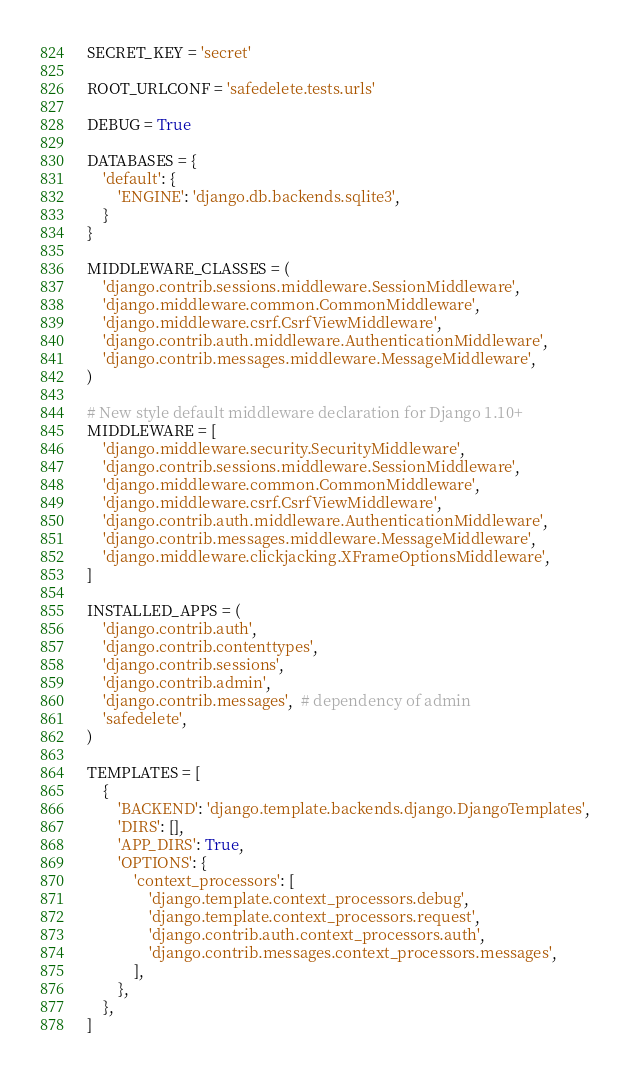<code> <loc_0><loc_0><loc_500><loc_500><_Python_>SECRET_KEY = 'secret'

ROOT_URLCONF = 'safedelete.tests.urls'

DEBUG = True

DATABASES = {
    'default': {
        'ENGINE': 'django.db.backends.sqlite3',
    }
}

MIDDLEWARE_CLASSES = (
    'django.contrib.sessions.middleware.SessionMiddleware',
    'django.middleware.common.CommonMiddleware',
    'django.middleware.csrf.CsrfViewMiddleware',
    'django.contrib.auth.middleware.AuthenticationMiddleware',
    'django.contrib.messages.middleware.MessageMiddleware',
)

# New style default middleware declaration for Django 1.10+
MIDDLEWARE = [
    'django.middleware.security.SecurityMiddleware',
    'django.contrib.sessions.middleware.SessionMiddleware',
    'django.middleware.common.CommonMiddleware',
    'django.middleware.csrf.CsrfViewMiddleware',
    'django.contrib.auth.middleware.AuthenticationMiddleware',
    'django.contrib.messages.middleware.MessageMiddleware',
    'django.middleware.clickjacking.XFrameOptionsMiddleware',
]

INSTALLED_APPS = (
    'django.contrib.auth',
    'django.contrib.contenttypes',
    'django.contrib.sessions',
    'django.contrib.admin',
    'django.contrib.messages',  # dependency of admin
    'safedelete',
)

TEMPLATES = [
    {
        'BACKEND': 'django.template.backends.django.DjangoTemplates',
        'DIRS': [],
        'APP_DIRS': True,
        'OPTIONS': {
            'context_processors': [
                'django.template.context_processors.debug',
                'django.template.context_processors.request',
                'django.contrib.auth.context_processors.auth',
                'django.contrib.messages.context_processors.messages',
            ],
        },
    },
]
</code> 